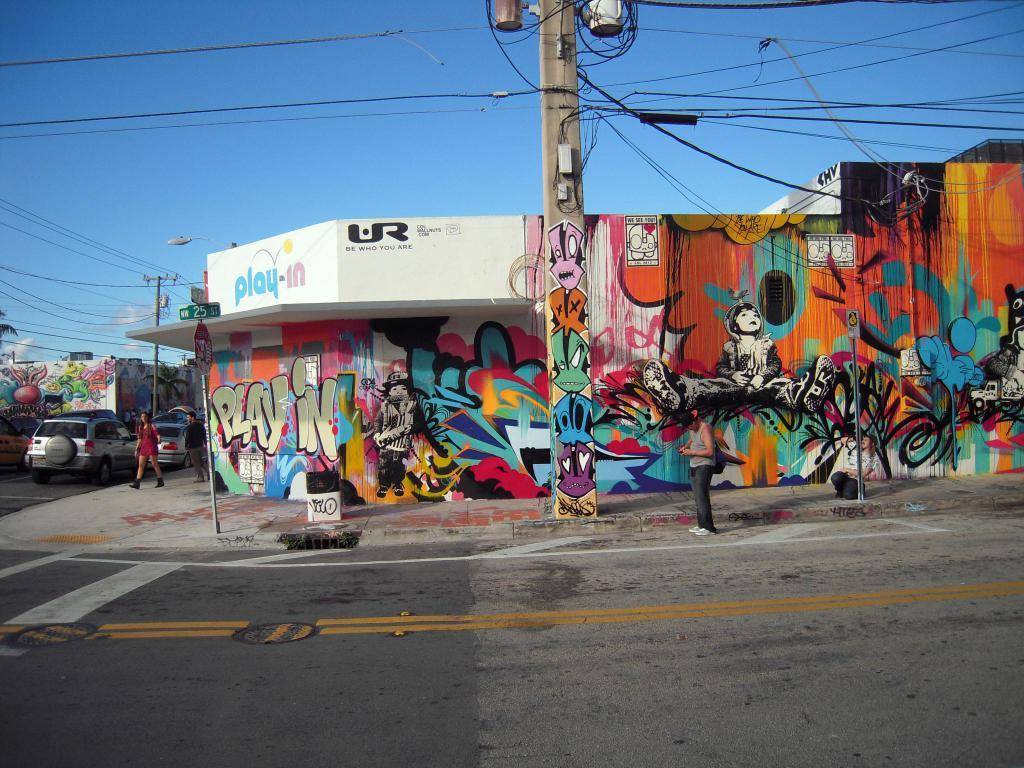What is the main subject of the image? The main subject of the image is a building with graffiti. What can be seen in front of the building? There is an electric pole in front of the building. Is there anyone present near the electric pole? Yes, a person is standing near the electric pole. What else can be seen in the image? There are cars visible on the road. What type of drain is visible in the image? There is no drain present in the image. How does the car change its color in the image? There is no car present in the image, so it cannot change its color. 